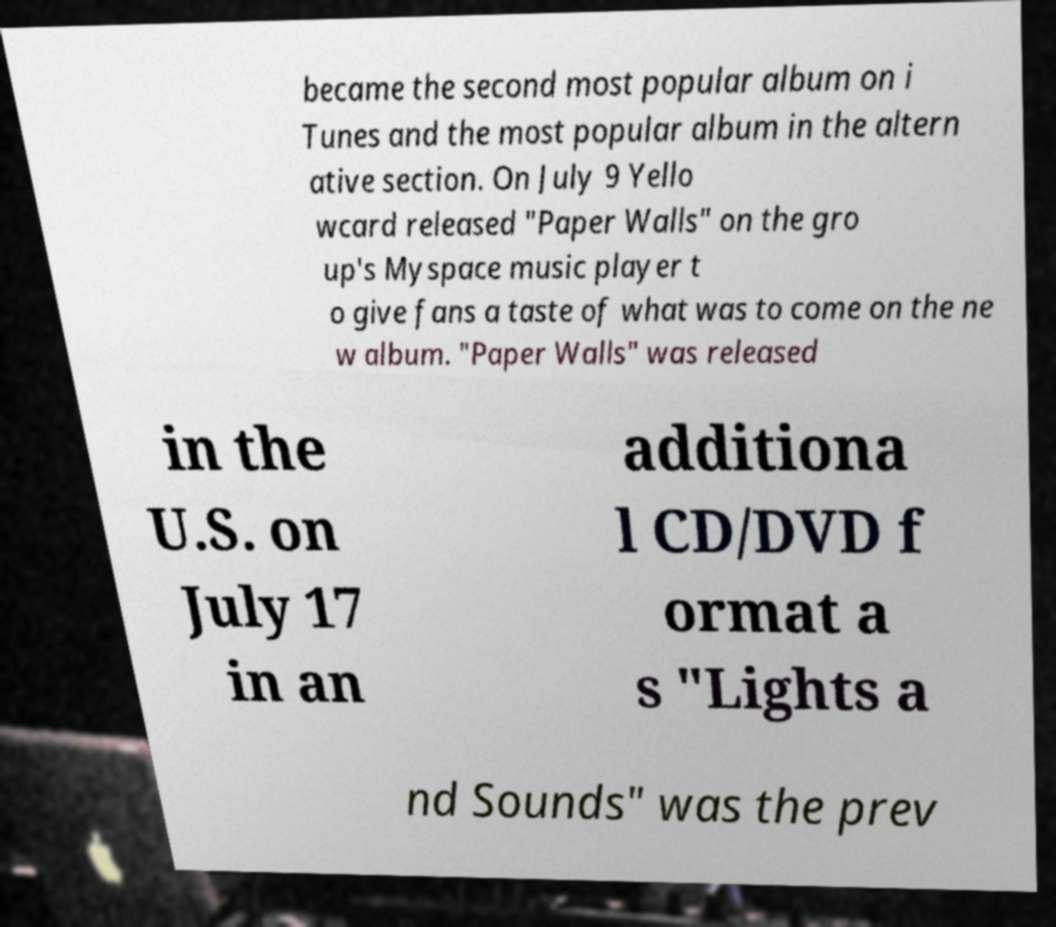What messages or text are displayed in this image? I need them in a readable, typed format. became the second most popular album on i Tunes and the most popular album in the altern ative section. On July 9 Yello wcard released "Paper Walls" on the gro up's Myspace music player t o give fans a taste of what was to come on the ne w album. "Paper Walls" was released in the U.S. on July 17 in an additiona l CD/DVD f ormat a s "Lights a nd Sounds" was the prev 